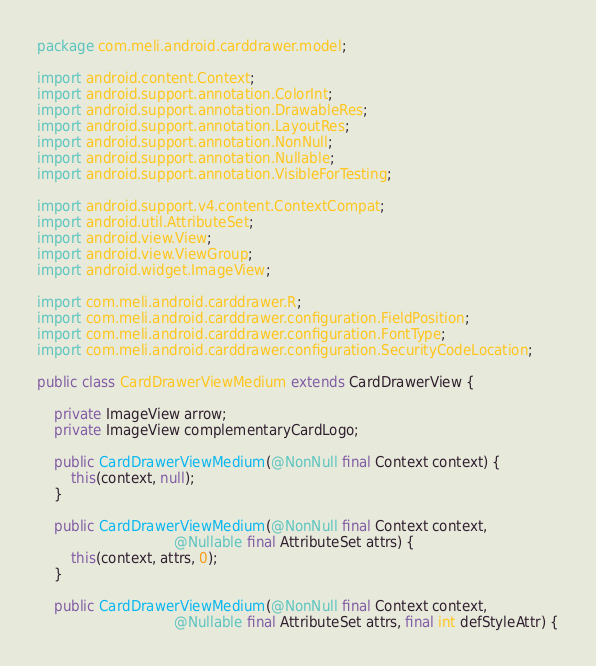Convert code to text. <code><loc_0><loc_0><loc_500><loc_500><_Java_>package com.meli.android.carddrawer.model;

import android.content.Context;
import android.support.annotation.ColorInt;
import android.support.annotation.DrawableRes;
import android.support.annotation.LayoutRes;
import android.support.annotation.NonNull;
import android.support.annotation.Nullable;
import android.support.annotation.VisibleForTesting;

import android.support.v4.content.ContextCompat;
import android.util.AttributeSet;
import android.view.View;
import android.view.ViewGroup;
import android.widget.ImageView;

import com.meli.android.carddrawer.R;
import com.meli.android.carddrawer.configuration.FieldPosition;
import com.meli.android.carddrawer.configuration.FontType;
import com.meli.android.carddrawer.configuration.SecurityCodeLocation;

public class CardDrawerViewMedium extends CardDrawerView {

    private ImageView arrow;
    private ImageView complementaryCardLogo;

    public CardDrawerViewMedium(@NonNull final Context context) {
        this(context, null);
    }

    public CardDrawerViewMedium(@NonNull final Context context,
                                @Nullable final AttributeSet attrs) {
        this(context, attrs, 0);
    }

    public CardDrawerViewMedium(@NonNull final Context context,
                                @Nullable final AttributeSet attrs, final int defStyleAttr) {</code> 